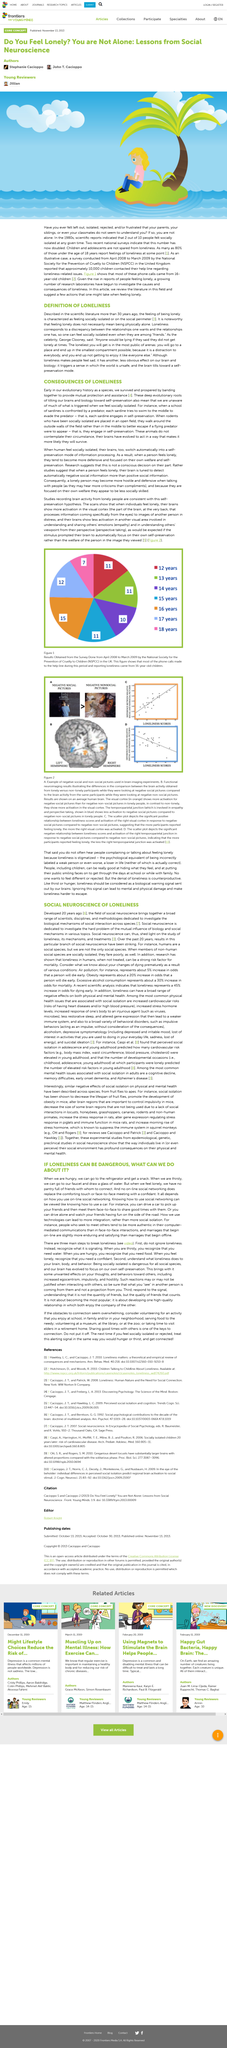Identify some key points in this picture. Loneliness can be a dangerous and harmful state that can negatively impact one's well-being, and the use of technology can be a helpful tool in countering its effects. In the scientific literature, loneliness was first described more than 30 years ago in its definition. It is not possible for an online social network to completely replace the comforting touch or face-to-face interaction with a friend, as social networking platforms cannot fully replicate the emotional and social benefits of in-person interactions. When rodents who have been socially isolated are left in an open field, they exhibit behaviors to preserve themselves, such as walking around the field instead of in the middle, to better escape potential flying predators. Feeling lonely does not necessarily mean being physically alone. 